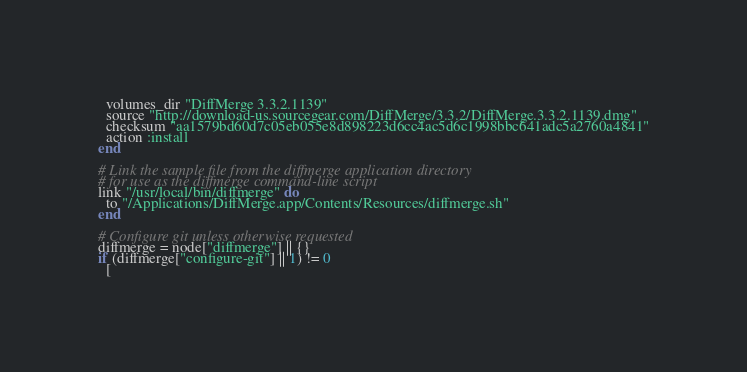<code> <loc_0><loc_0><loc_500><loc_500><_Ruby_>  volumes_dir "DiffMerge 3.3.2.1139"
  source "http://download-us.sourcegear.com/DiffMerge/3.3.2/DiffMerge.3.3.2.1139.dmg"
  checksum "aa1579bd60d7c05eb055e8d898223d6cc4ac5d6c1998bbc641adc5a2760a4841"
  action :install
end

# Link the sample file from the diffmerge application directory
# for use as the diffmerge command-line script
link "/usr/local/bin/diffmerge" do
  to "/Applications/DiffMerge.app/Contents/Resources/diffmerge.sh"
end

# Configure git unless otherwise requested
diffmerge = node["diffmerge"] || {}
if (diffmerge["configure-git"] || 1) != 0
  [</code> 